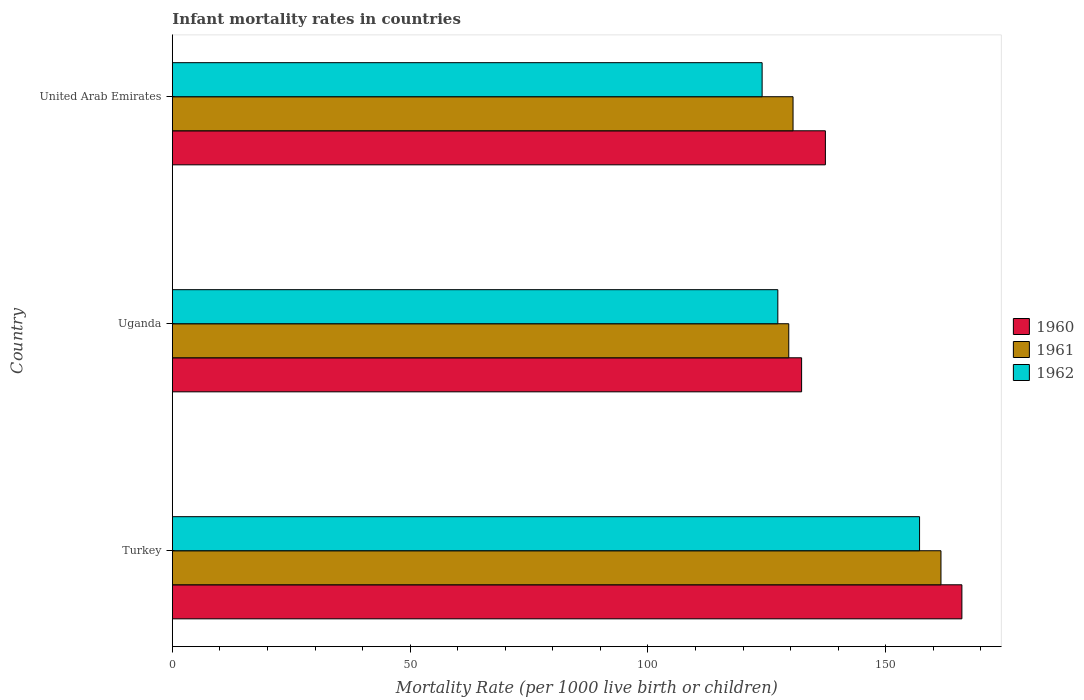How many different coloured bars are there?
Your answer should be very brief. 3. How many groups of bars are there?
Your answer should be very brief. 3. Are the number of bars on each tick of the Y-axis equal?
Offer a terse response. Yes. How many bars are there on the 3rd tick from the top?
Make the answer very short. 3. How many bars are there on the 3rd tick from the bottom?
Offer a very short reply. 3. What is the label of the 2nd group of bars from the top?
Give a very brief answer. Uganda. What is the infant mortality rate in 1960 in United Arab Emirates?
Keep it short and to the point. 137.3. Across all countries, what is the maximum infant mortality rate in 1960?
Your response must be concise. 166. Across all countries, what is the minimum infant mortality rate in 1962?
Offer a terse response. 124. In which country was the infant mortality rate in 1962 minimum?
Provide a short and direct response. United Arab Emirates. What is the total infant mortality rate in 1960 in the graph?
Your answer should be very brief. 435.6. What is the difference between the infant mortality rate in 1961 in Uganda and the infant mortality rate in 1960 in Turkey?
Give a very brief answer. -36.4. What is the average infant mortality rate in 1960 per country?
Your answer should be compact. 145.2. What is the difference between the infant mortality rate in 1962 and infant mortality rate in 1960 in United Arab Emirates?
Offer a very short reply. -13.3. What is the ratio of the infant mortality rate in 1960 in Turkey to that in Uganda?
Provide a succinct answer. 1.25. Is the infant mortality rate in 1962 in Turkey less than that in Uganda?
Provide a short and direct response. No. What is the difference between the highest and the second highest infant mortality rate in 1962?
Give a very brief answer. 29.8. What is the difference between the highest and the lowest infant mortality rate in 1961?
Your response must be concise. 32. Is the sum of the infant mortality rate in 1960 in Turkey and United Arab Emirates greater than the maximum infant mortality rate in 1962 across all countries?
Make the answer very short. Yes. How many bars are there?
Make the answer very short. 9. Are all the bars in the graph horizontal?
Your answer should be compact. Yes. How many countries are there in the graph?
Give a very brief answer. 3. Are the values on the major ticks of X-axis written in scientific E-notation?
Your response must be concise. No. Does the graph contain grids?
Provide a short and direct response. No. How are the legend labels stacked?
Provide a short and direct response. Vertical. What is the title of the graph?
Your response must be concise. Infant mortality rates in countries. Does "1967" appear as one of the legend labels in the graph?
Offer a very short reply. No. What is the label or title of the X-axis?
Keep it short and to the point. Mortality Rate (per 1000 live birth or children). What is the label or title of the Y-axis?
Your response must be concise. Country. What is the Mortality Rate (per 1000 live birth or children) of 1960 in Turkey?
Keep it short and to the point. 166. What is the Mortality Rate (per 1000 live birth or children) of 1961 in Turkey?
Offer a very short reply. 161.6. What is the Mortality Rate (per 1000 live birth or children) in 1962 in Turkey?
Offer a very short reply. 157.1. What is the Mortality Rate (per 1000 live birth or children) in 1960 in Uganda?
Provide a succinct answer. 132.3. What is the Mortality Rate (per 1000 live birth or children) of 1961 in Uganda?
Offer a very short reply. 129.6. What is the Mortality Rate (per 1000 live birth or children) in 1962 in Uganda?
Offer a very short reply. 127.3. What is the Mortality Rate (per 1000 live birth or children) in 1960 in United Arab Emirates?
Keep it short and to the point. 137.3. What is the Mortality Rate (per 1000 live birth or children) of 1961 in United Arab Emirates?
Your answer should be very brief. 130.5. What is the Mortality Rate (per 1000 live birth or children) in 1962 in United Arab Emirates?
Keep it short and to the point. 124. Across all countries, what is the maximum Mortality Rate (per 1000 live birth or children) of 1960?
Ensure brevity in your answer.  166. Across all countries, what is the maximum Mortality Rate (per 1000 live birth or children) in 1961?
Keep it short and to the point. 161.6. Across all countries, what is the maximum Mortality Rate (per 1000 live birth or children) in 1962?
Give a very brief answer. 157.1. Across all countries, what is the minimum Mortality Rate (per 1000 live birth or children) of 1960?
Provide a succinct answer. 132.3. Across all countries, what is the minimum Mortality Rate (per 1000 live birth or children) in 1961?
Your answer should be compact. 129.6. Across all countries, what is the minimum Mortality Rate (per 1000 live birth or children) in 1962?
Your response must be concise. 124. What is the total Mortality Rate (per 1000 live birth or children) of 1960 in the graph?
Your response must be concise. 435.6. What is the total Mortality Rate (per 1000 live birth or children) of 1961 in the graph?
Offer a terse response. 421.7. What is the total Mortality Rate (per 1000 live birth or children) of 1962 in the graph?
Keep it short and to the point. 408.4. What is the difference between the Mortality Rate (per 1000 live birth or children) of 1960 in Turkey and that in Uganda?
Keep it short and to the point. 33.7. What is the difference between the Mortality Rate (per 1000 live birth or children) of 1961 in Turkey and that in Uganda?
Keep it short and to the point. 32. What is the difference between the Mortality Rate (per 1000 live birth or children) of 1962 in Turkey and that in Uganda?
Your answer should be compact. 29.8. What is the difference between the Mortality Rate (per 1000 live birth or children) in 1960 in Turkey and that in United Arab Emirates?
Give a very brief answer. 28.7. What is the difference between the Mortality Rate (per 1000 live birth or children) in 1961 in Turkey and that in United Arab Emirates?
Keep it short and to the point. 31.1. What is the difference between the Mortality Rate (per 1000 live birth or children) of 1962 in Turkey and that in United Arab Emirates?
Keep it short and to the point. 33.1. What is the difference between the Mortality Rate (per 1000 live birth or children) of 1960 in Uganda and that in United Arab Emirates?
Provide a short and direct response. -5. What is the difference between the Mortality Rate (per 1000 live birth or children) in 1962 in Uganda and that in United Arab Emirates?
Your answer should be very brief. 3.3. What is the difference between the Mortality Rate (per 1000 live birth or children) in 1960 in Turkey and the Mortality Rate (per 1000 live birth or children) in 1961 in Uganda?
Ensure brevity in your answer.  36.4. What is the difference between the Mortality Rate (per 1000 live birth or children) of 1960 in Turkey and the Mortality Rate (per 1000 live birth or children) of 1962 in Uganda?
Your answer should be very brief. 38.7. What is the difference between the Mortality Rate (per 1000 live birth or children) in 1961 in Turkey and the Mortality Rate (per 1000 live birth or children) in 1962 in Uganda?
Keep it short and to the point. 34.3. What is the difference between the Mortality Rate (per 1000 live birth or children) of 1960 in Turkey and the Mortality Rate (per 1000 live birth or children) of 1961 in United Arab Emirates?
Keep it short and to the point. 35.5. What is the difference between the Mortality Rate (per 1000 live birth or children) of 1960 in Turkey and the Mortality Rate (per 1000 live birth or children) of 1962 in United Arab Emirates?
Your response must be concise. 42. What is the difference between the Mortality Rate (per 1000 live birth or children) of 1961 in Turkey and the Mortality Rate (per 1000 live birth or children) of 1962 in United Arab Emirates?
Keep it short and to the point. 37.6. What is the difference between the Mortality Rate (per 1000 live birth or children) in 1960 in Uganda and the Mortality Rate (per 1000 live birth or children) in 1961 in United Arab Emirates?
Your answer should be very brief. 1.8. What is the difference between the Mortality Rate (per 1000 live birth or children) in 1960 in Uganda and the Mortality Rate (per 1000 live birth or children) in 1962 in United Arab Emirates?
Make the answer very short. 8.3. What is the difference between the Mortality Rate (per 1000 live birth or children) of 1961 in Uganda and the Mortality Rate (per 1000 live birth or children) of 1962 in United Arab Emirates?
Give a very brief answer. 5.6. What is the average Mortality Rate (per 1000 live birth or children) of 1960 per country?
Offer a terse response. 145.2. What is the average Mortality Rate (per 1000 live birth or children) of 1961 per country?
Make the answer very short. 140.57. What is the average Mortality Rate (per 1000 live birth or children) in 1962 per country?
Provide a short and direct response. 136.13. What is the difference between the Mortality Rate (per 1000 live birth or children) of 1960 and Mortality Rate (per 1000 live birth or children) of 1961 in Turkey?
Provide a short and direct response. 4.4. What is the difference between the Mortality Rate (per 1000 live birth or children) of 1960 and Mortality Rate (per 1000 live birth or children) of 1962 in Turkey?
Give a very brief answer. 8.9. What is the difference between the Mortality Rate (per 1000 live birth or children) in 1960 and Mortality Rate (per 1000 live birth or children) in 1961 in Uganda?
Provide a succinct answer. 2.7. What is the difference between the Mortality Rate (per 1000 live birth or children) of 1961 and Mortality Rate (per 1000 live birth or children) of 1962 in Uganda?
Give a very brief answer. 2.3. What is the difference between the Mortality Rate (per 1000 live birth or children) in 1960 and Mortality Rate (per 1000 live birth or children) in 1962 in United Arab Emirates?
Provide a short and direct response. 13.3. What is the difference between the Mortality Rate (per 1000 live birth or children) of 1961 and Mortality Rate (per 1000 live birth or children) of 1962 in United Arab Emirates?
Make the answer very short. 6.5. What is the ratio of the Mortality Rate (per 1000 live birth or children) of 1960 in Turkey to that in Uganda?
Ensure brevity in your answer.  1.25. What is the ratio of the Mortality Rate (per 1000 live birth or children) of 1961 in Turkey to that in Uganda?
Keep it short and to the point. 1.25. What is the ratio of the Mortality Rate (per 1000 live birth or children) of 1962 in Turkey to that in Uganda?
Your answer should be compact. 1.23. What is the ratio of the Mortality Rate (per 1000 live birth or children) in 1960 in Turkey to that in United Arab Emirates?
Provide a short and direct response. 1.21. What is the ratio of the Mortality Rate (per 1000 live birth or children) in 1961 in Turkey to that in United Arab Emirates?
Your answer should be very brief. 1.24. What is the ratio of the Mortality Rate (per 1000 live birth or children) of 1962 in Turkey to that in United Arab Emirates?
Provide a succinct answer. 1.27. What is the ratio of the Mortality Rate (per 1000 live birth or children) of 1960 in Uganda to that in United Arab Emirates?
Keep it short and to the point. 0.96. What is the ratio of the Mortality Rate (per 1000 live birth or children) in 1961 in Uganda to that in United Arab Emirates?
Provide a short and direct response. 0.99. What is the ratio of the Mortality Rate (per 1000 live birth or children) in 1962 in Uganda to that in United Arab Emirates?
Provide a short and direct response. 1.03. What is the difference between the highest and the second highest Mortality Rate (per 1000 live birth or children) in 1960?
Keep it short and to the point. 28.7. What is the difference between the highest and the second highest Mortality Rate (per 1000 live birth or children) in 1961?
Offer a very short reply. 31.1. What is the difference between the highest and the second highest Mortality Rate (per 1000 live birth or children) of 1962?
Offer a very short reply. 29.8. What is the difference between the highest and the lowest Mortality Rate (per 1000 live birth or children) in 1960?
Ensure brevity in your answer.  33.7. What is the difference between the highest and the lowest Mortality Rate (per 1000 live birth or children) in 1962?
Keep it short and to the point. 33.1. 